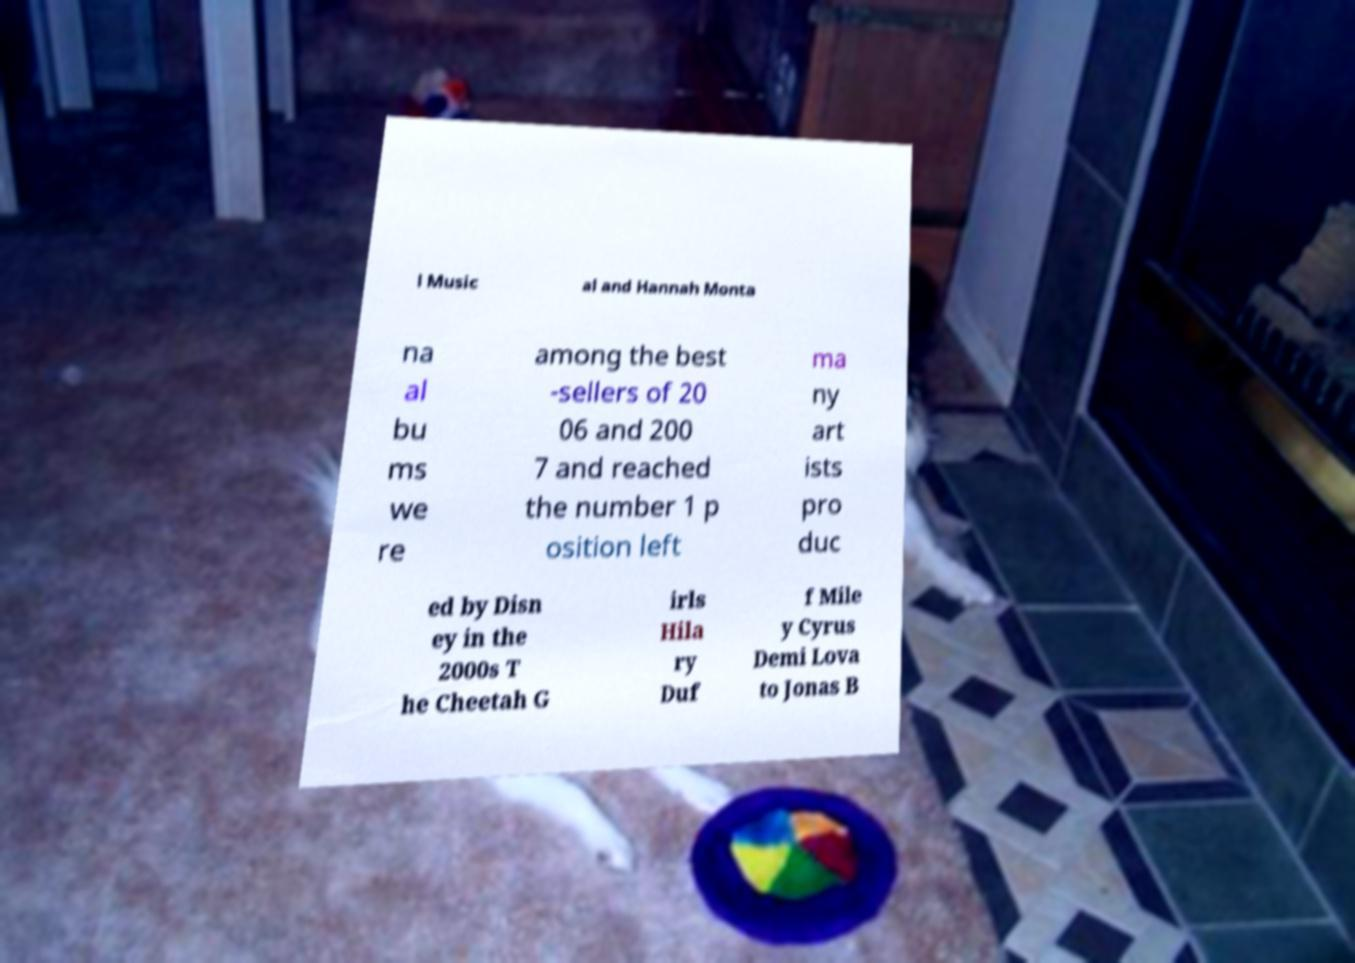There's text embedded in this image that I need extracted. Can you transcribe it verbatim? l Music al and Hannah Monta na al bu ms we re among the best -sellers of 20 06 and 200 7 and reached the number 1 p osition left ma ny art ists pro duc ed by Disn ey in the 2000s T he Cheetah G irls Hila ry Duf f Mile y Cyrus Demi Lova to Jonas B 